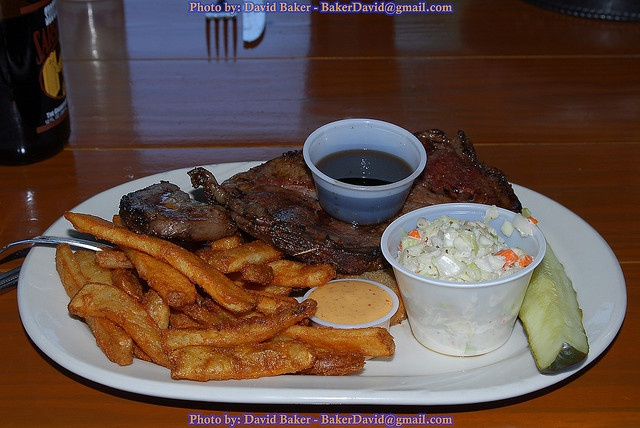Describe the objects in this image and their specific colors. I can see dining table in black, maroon, darkgray, gray, and brown tones, cup in black, darkgray, lightgray, and gray tones, cup in black, gray, darkgray, and navy tones, bottle in black, olive, gray, and maroon tones, and fork in black, purple, navy, and darkblue tones in this image. 